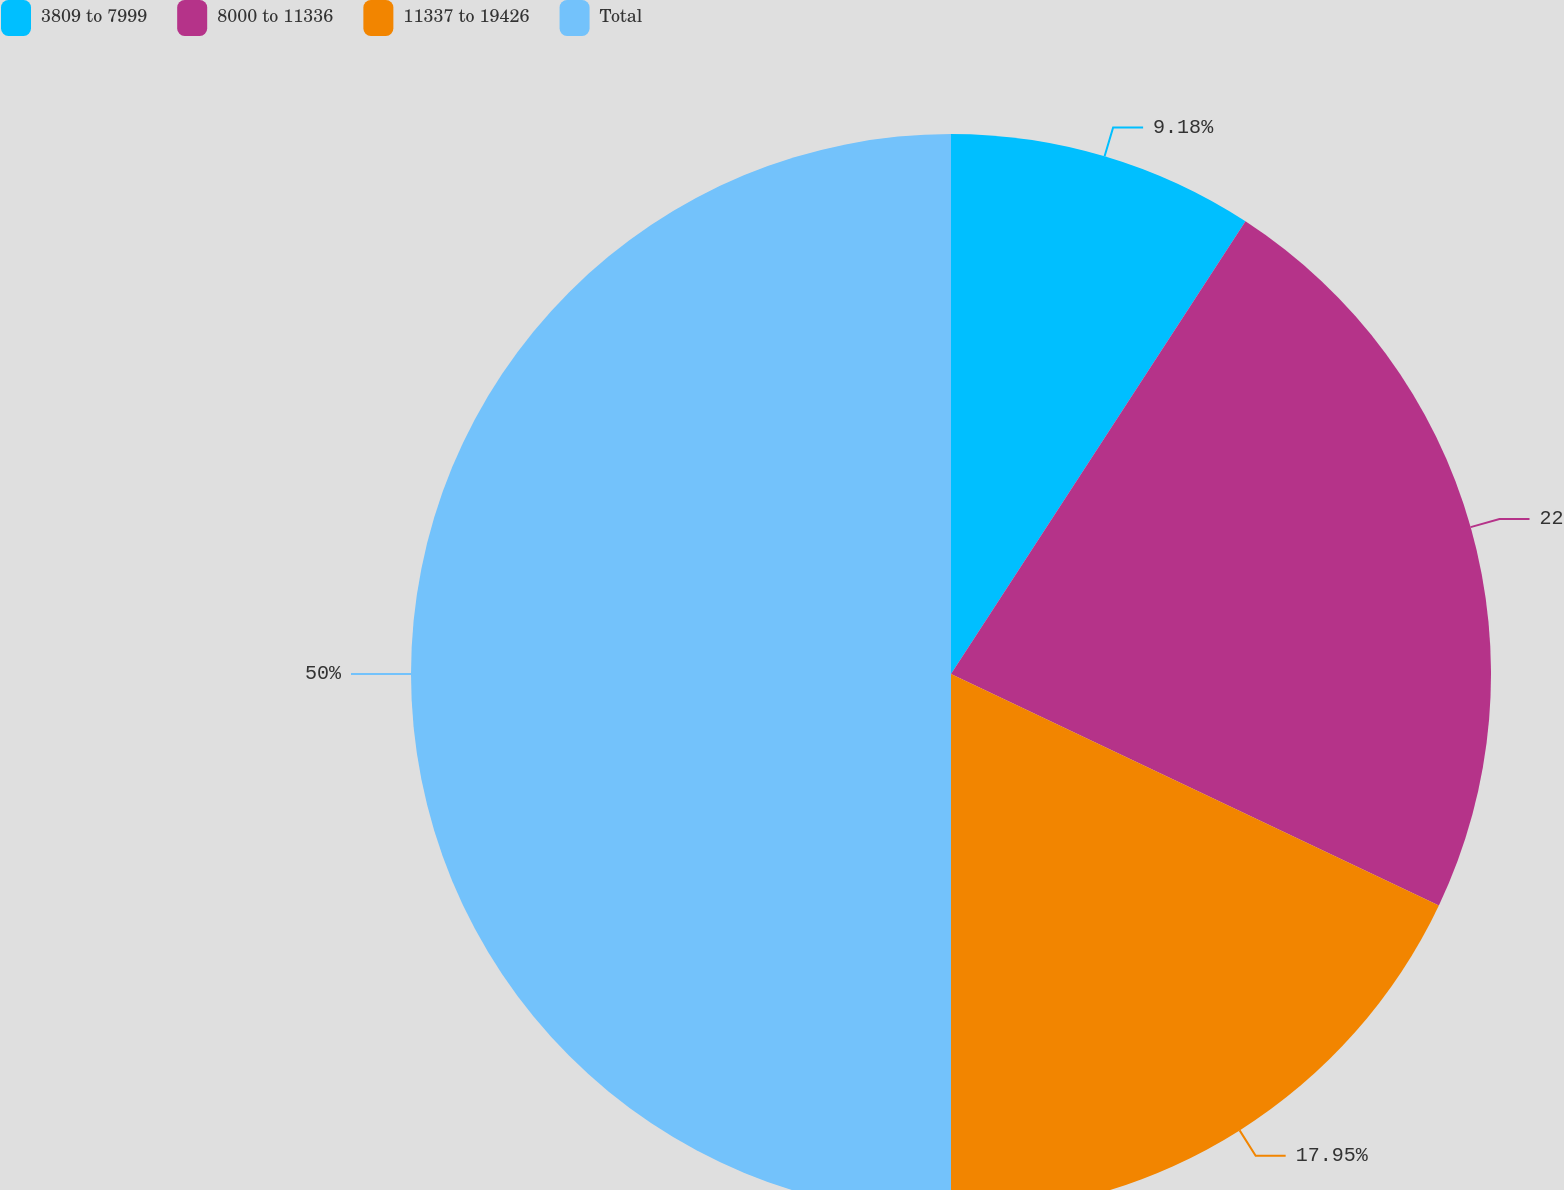Convert chart. <chart><loc_0><loc_0><loc_500><loc_500><pie_chart><fcel>3809 to 7999<fcel>8000 to 11336<fcel>11337 to 19426<fcel>Total<nl><fcel>9.18%<fcel>22.87%<fcel>17.95%<fcel>50.0%<nl></chart> 